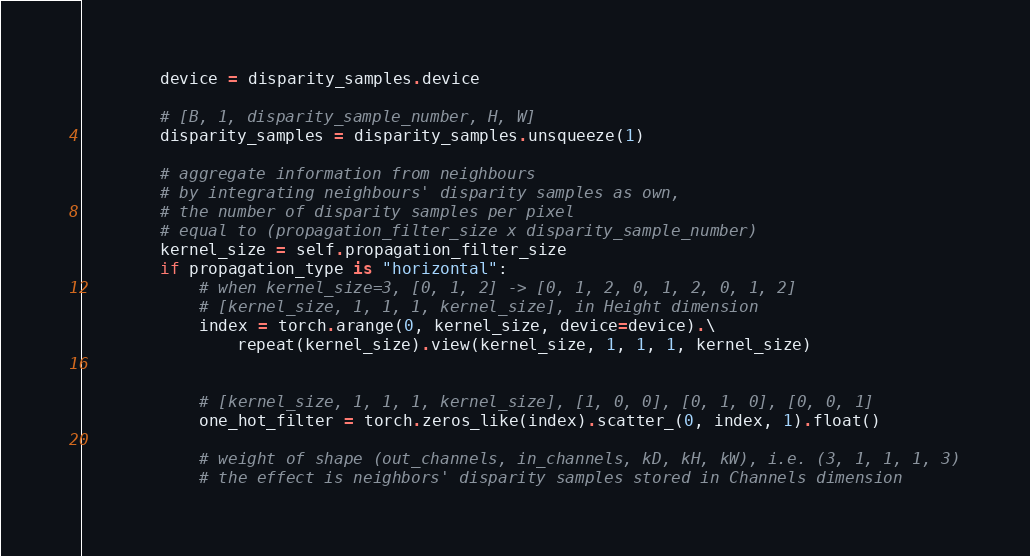Convert code to text. <code><loc_0><loc_0><loc_500><loc_500><_Python_>
        device = disparity_samples.device

        # [B, 1, disparity_sample_number, H, W]
        disparity_samples = disparity_samples.unsqueeze(1)

        # aggregate information from neighbours
        # by integrating neighbours' disparity samples as own,
        # the number of disparity samples per pixel
        # equal to (propagation_filter_size x disparity_sample_number)
        kernel_size = self.propagation_filter_size
        if propagation_type is "horizontal":
            # when kernel_size=3, [0, 1, 2] -> [0, 1, 2, 0, 1, 2, 0, 1, 2]
            # [kernel_size, 1, 1, 1, kernel_size], in Height dimension
            index = torch.arange(0, kernel_size, device=device).\
                repeat(kernel_size).view(kernel_size, 1, 1, 1, kernel_size)


            # [kernel_size, 1, 1, 1, kernel_size], [1, 0, 0], [0, 1, 0], [0, 0, 1]
            one_hot_filter = torch.zeros_like(index).scatter_(0, index, 1).float()

            # weight of shape (out_channels, in_channels, kD, kH, kW), i.e. (3, 1, 1, 1, 3)
            # the effect is neighbors' disparity samples stored in Channels dimension</code> 